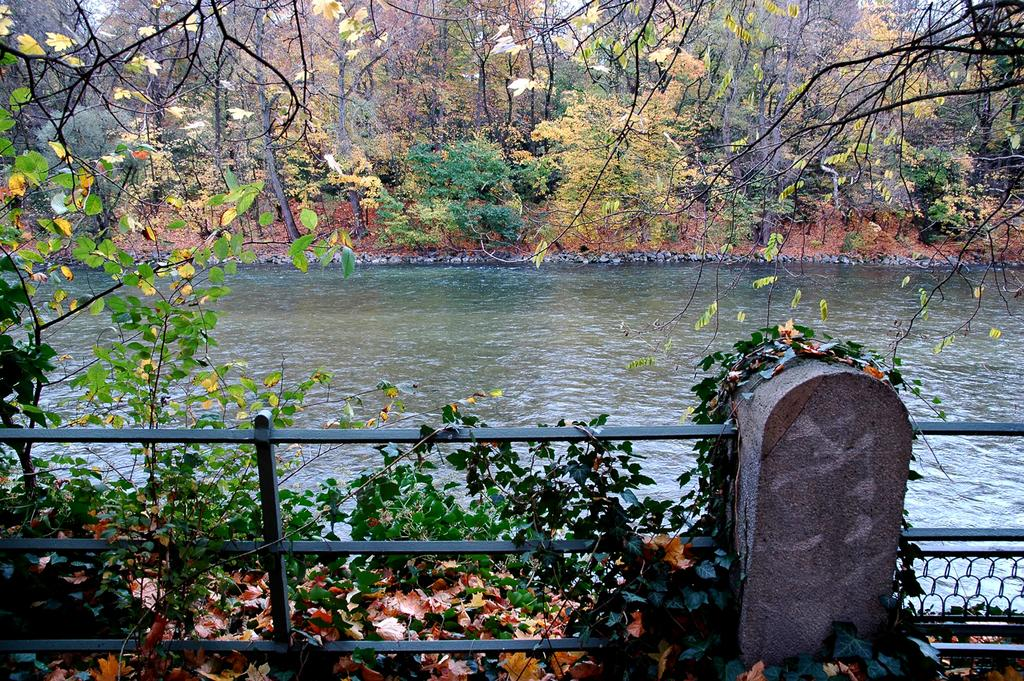What type of vegetation can be seen in the image? There are trees in the image. Where are the trees located in the image? The trees are at the top of the image. What else can be seen in the image besides trees? There is water and sky visible in the image. Where is the water located in the image? The water is in the middle of the image. What is visible at the top of the image? The sky is at the top of the image. What type of pets are sitting on the trees in the image? There are no pets present in the image; it only features trees, water, and sky. What wish can be granted by the trees in the image? There is no mention of wishes or magical elements in the image; it simply depicts trees, water, and sky. 